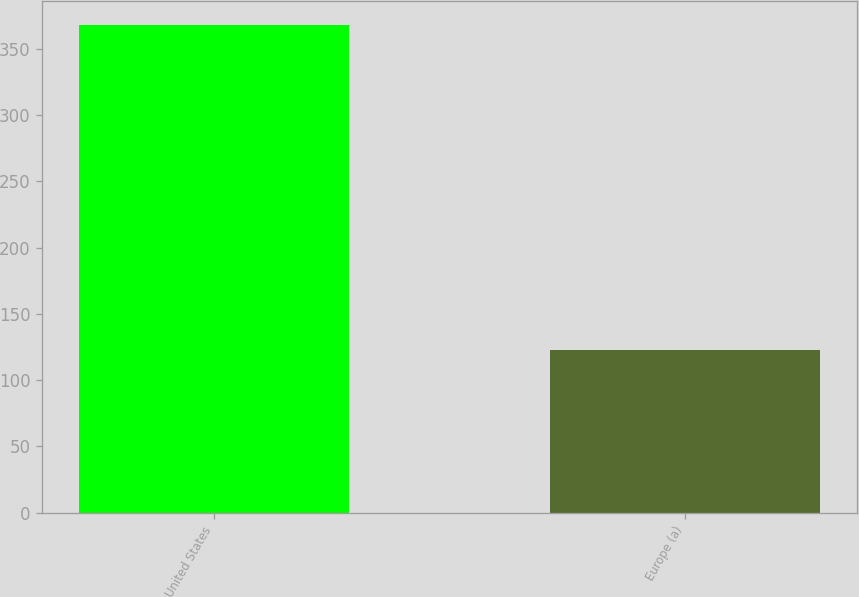Convert chart to OTSL. <chart><loc_0><loc_0><loc_500><loc_500><bar_chart><fcel>United States<fcel>Europe (a)<nl><fcel>368<fcel>123<nl></chart> 